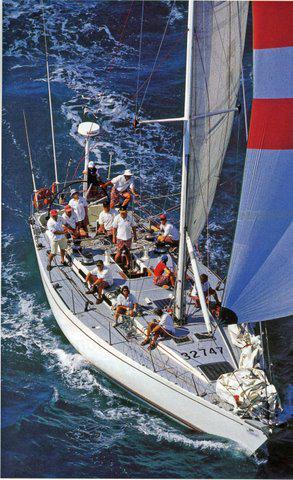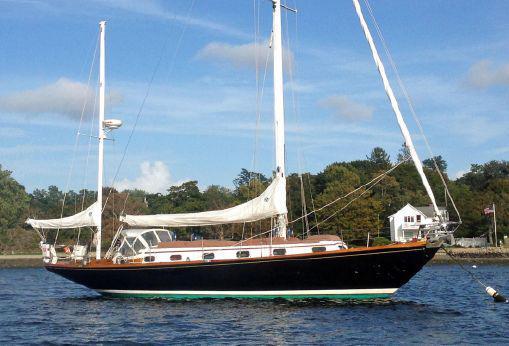The first image is the image on the left, the second image is the image on the right. Examine the images to the left and right. Is the description "One boat contains multiple people and creates white spray as it moves through water with unfurled sails, while the other boat is still and has furled sails." accurate? Answer yes or no. Yes. The first image is the image on the left, the second image is the image on the right. For the images shown, is this caption "The left and right image contains the same number of sailboats with one with no sails out." true? Answer yes or no. Yes. 